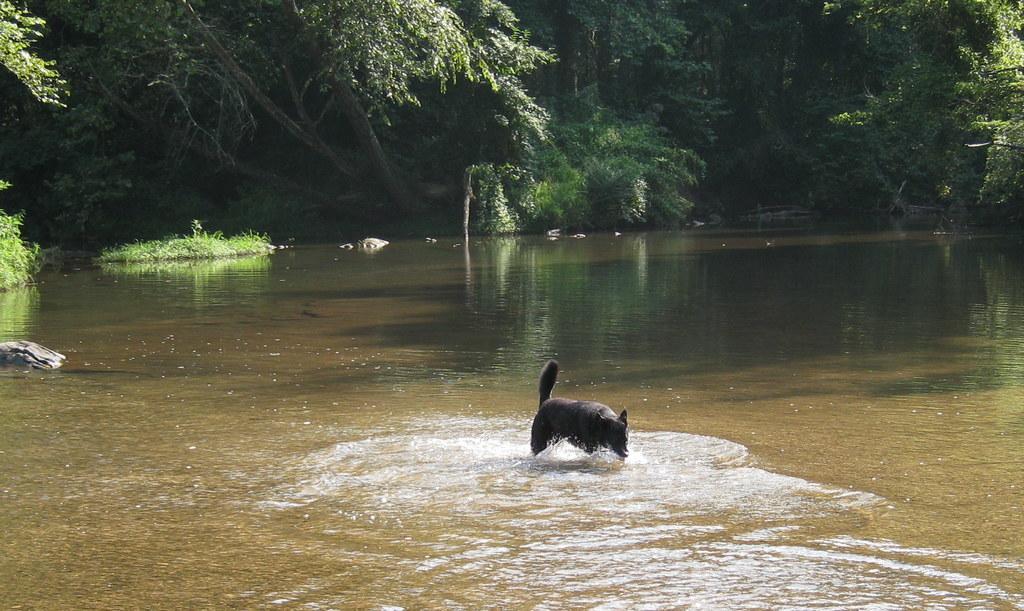How would you summarize this image in a sentence or two? In this image we can see a dog on the surface of the lake. In the background we can see many trees. 